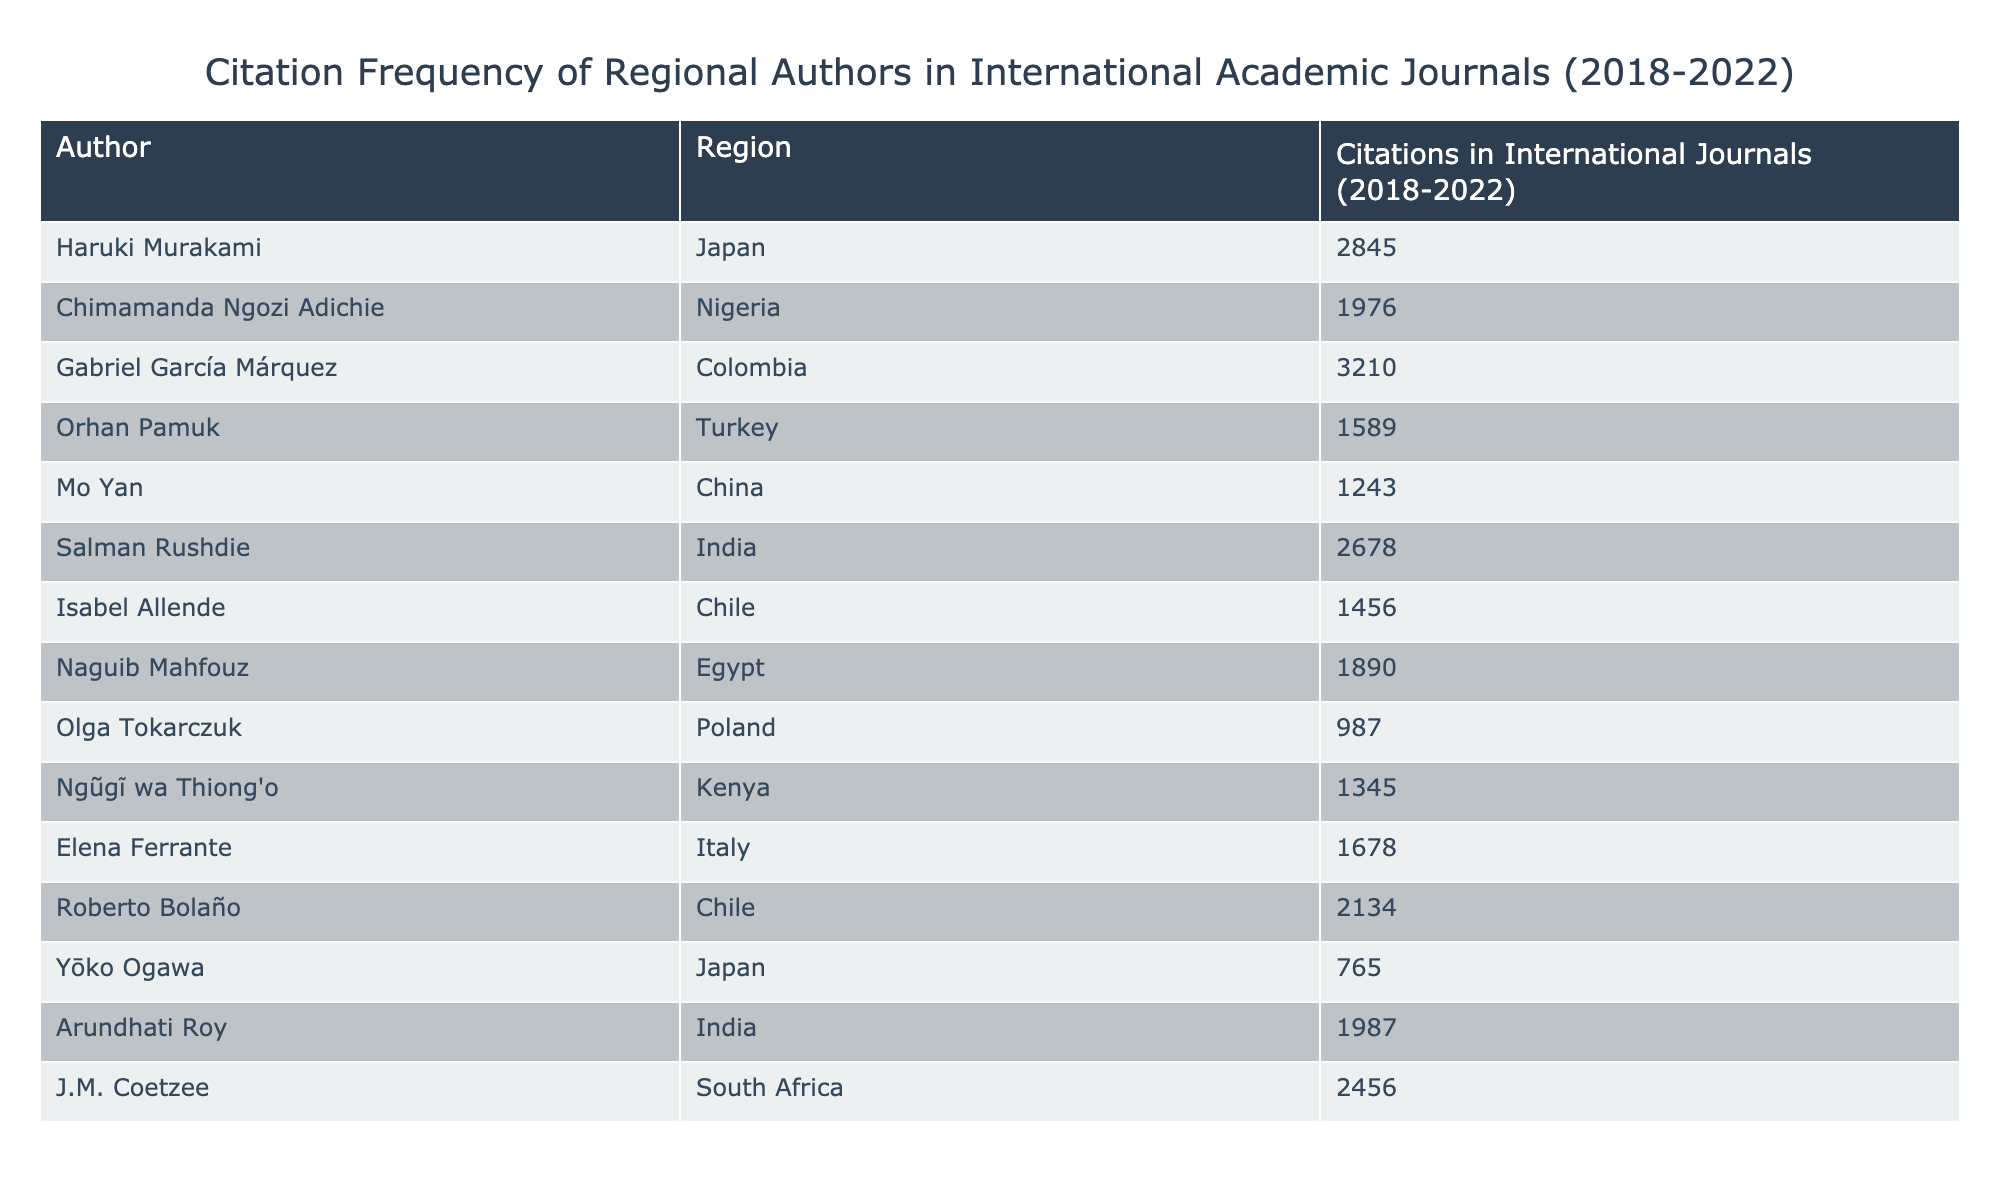What is the total number of citations for Gabriel García Márquez? Gabriel García Márquez has 3210 citations in international journals according to the table.
Answer: 3210 Which author has the highest citation count? The author with the highest citation count is Gabriel García Márquez with 3210 citations.
Answer: Gabriel García Márquez What is the average citation count of authors from Japan? The authors from Japan are Haruki Murakami (2845) and Yōko Ogawa (765). The sum of their citations is 2845 + 765 = 3610. There are 2 authors, so the average citation count is 3610 / 2 = 1805.
Answer: 1805 Is Chimamanda Ngozi Adichie cited more than Naguib Mahfouz? Chimamanda Ngozi Adichie has 1976 citations, while Naguib Mahfouz has 1890 citations. Since 1976 is greater than 1890, the statement is true.
Answer: Yes What is the difference in citation counts between the most cited author and the least cited author? The most cited author is Gabriel García Márquez with 3210 citations, and the least cited author is Olga Tokarczuk with 987 citations. The difference is 3210 - 987 = 2223.
Answer: 2223 Which regions have authors that have more than 2000 citations? The authors with more than 2000 citations are Gabriel García Márquez (Colombia - 3210), Salman Rushdie (India - 2678), Haruki Murakami (Japan - 2845), and J.M. Coetzee (South Africa - 2456). Their regions are Colombia, India, Japan, and South Africa respectively.
Answer: Colombia, India, Japan, South Africa What is the total number of citations for authors from Africa? The authors from Africa are Chimamanda Ngozi Adichie (1976), Orhan Pamuk (1589), and J.M. Coetzee (2456). The total citations are 1976 + 2456 + 1890 (from Naguib Mahfouz) = 6322.
Answer: 6322 How many authors have fewer than 1500 citations? The authors with fewer than 1500 citations are Mo Yan (1243), Isabel Allende (1456), and Olga Tokarczuk (987), totaling 3 authors.
Answer: 3 Which author has citations closest to 2000? Arundhati Roy with 1987 citations is closest to 2000, as it is only 13 citations away.
Answer: Arundhati Roy 